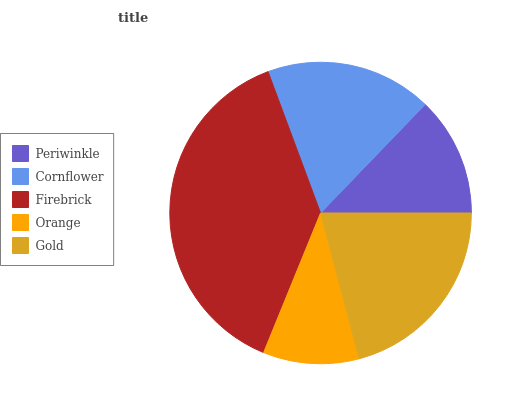Is Orange the minimum?
Answer yes or no. Yes. Is Firebrick the maximum?
Answer yes or no. Yes. Is Cornflower the minimum?
Answer yes or no. No. Is Cornflower the maximum?
Answer yes or no. No. Is Cornflower greater than Periwinkle?
Answer yes or no. Yes. Is Periwinkle less than Cornflower?
Answer yes or no. Yes. Is Periwinkle greater than Cornflower?
Answer yes or no. No. Is Cornflower less than Periwinkle?
Answer yes or no. No. Is Cornflower the high median?
Answer yes or no. Yes. Is Cornflower the low median?
Answer yes or no. Yes. Is Gold the high median?
Answer yes or no. No. Is Gold the low median?
Answer yes or no. No. 